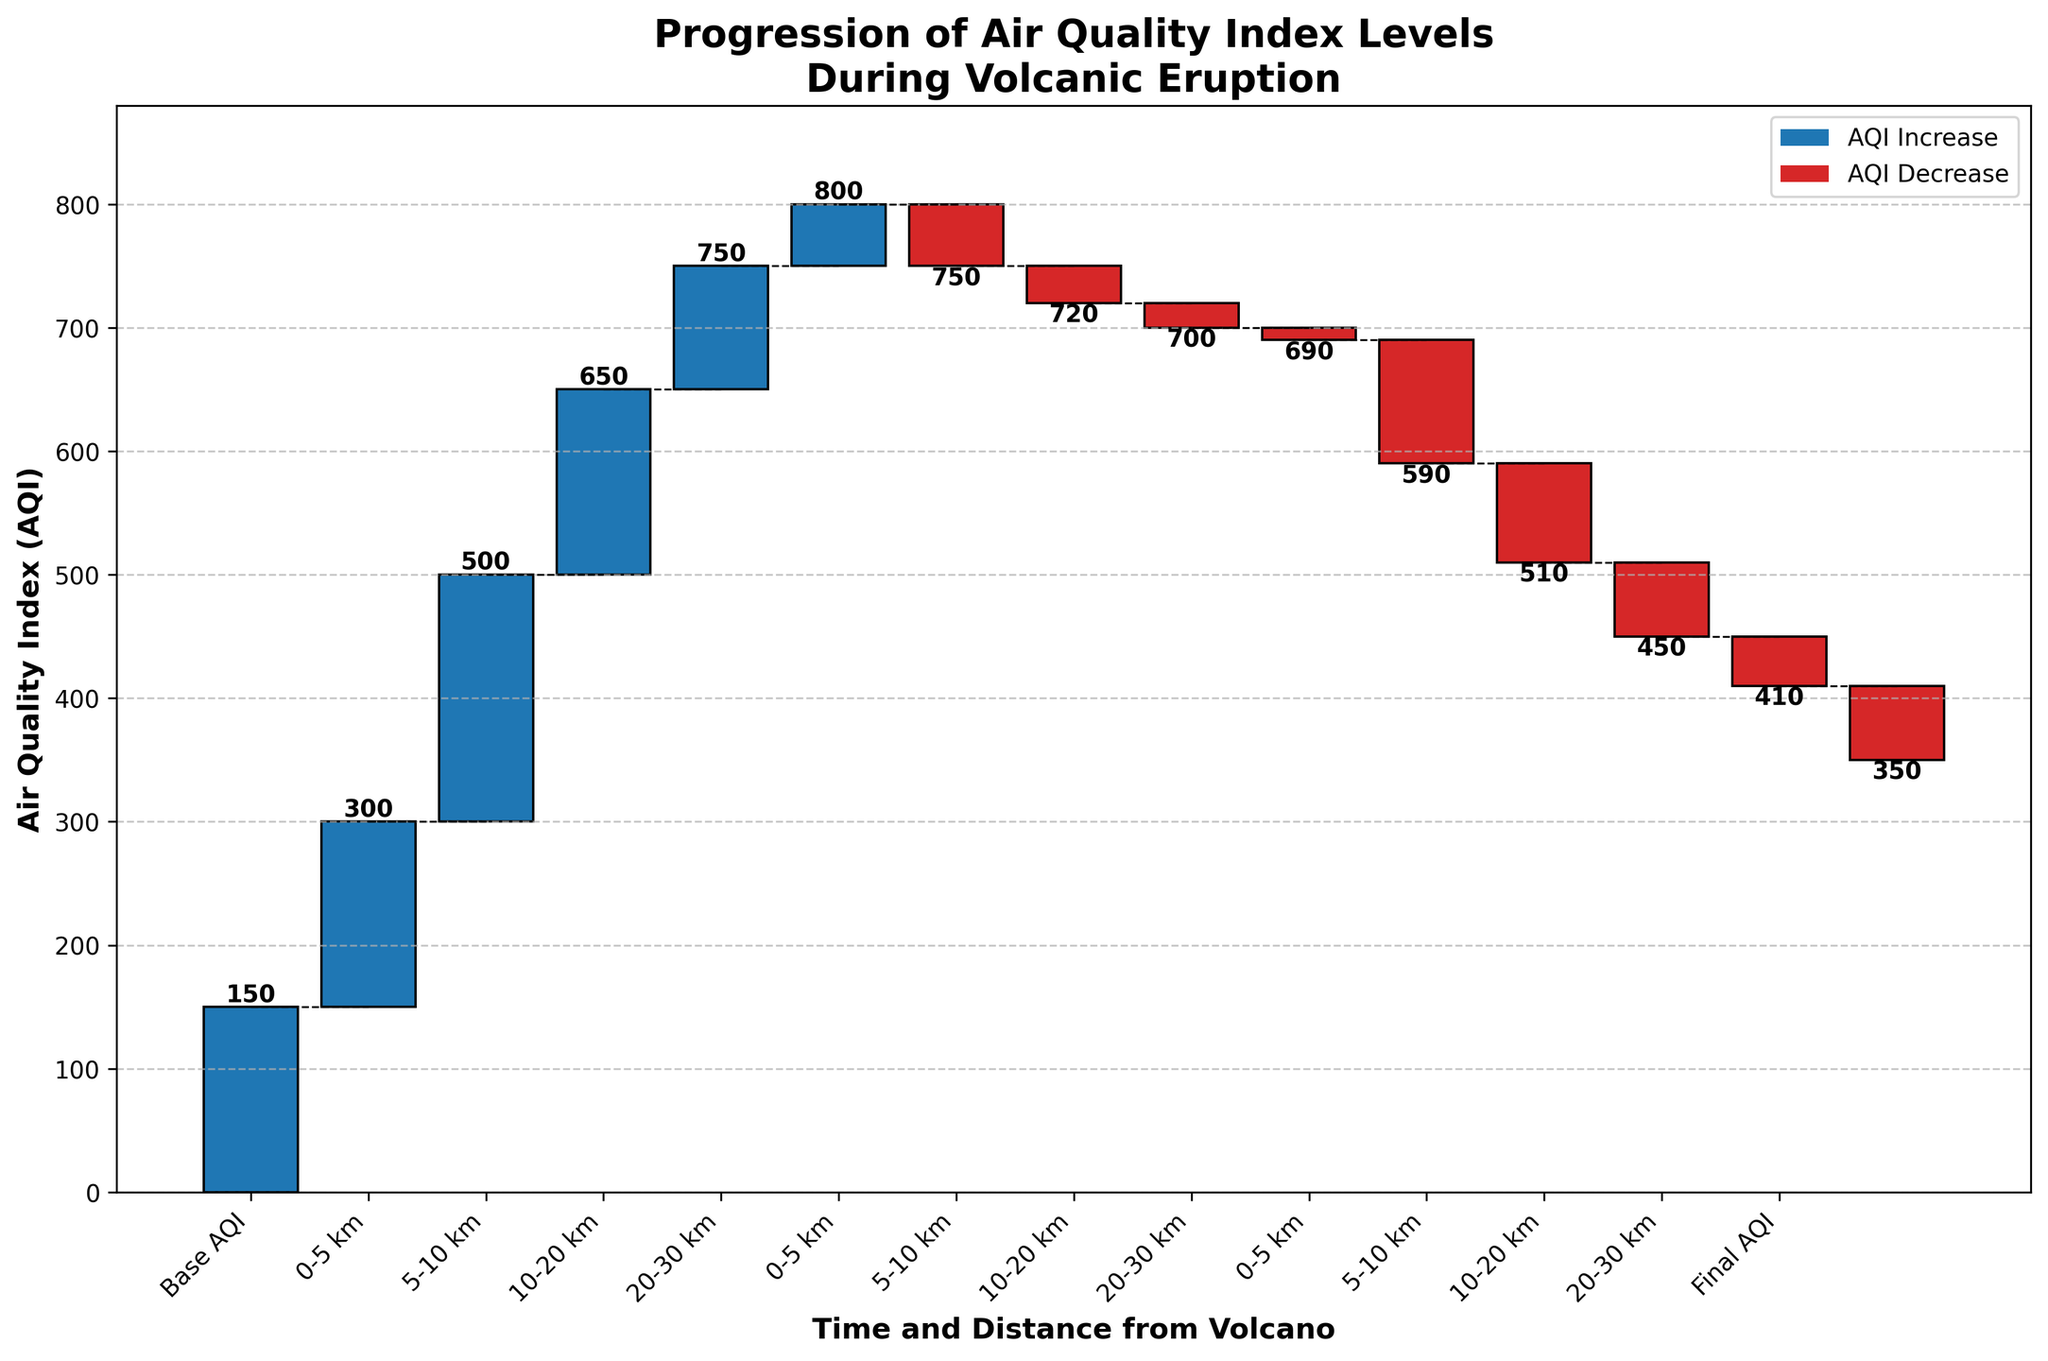what's the title of the chart? The title of the chart is displayed at the top and reads 'Progression of Air Quality Index Levels During Volcanic Eruption'.
Answer: Progression of Air Quality Index Levels During Volcanic Eruption How many intervals are depicted in the waterfall chart? The chart shows intervals from 'Base AQI' to 'Final AQI', covering multiple time and distance segments including 4 area segments at 6 hours, 4 segments at 12 hours, and 4 segments at 24 hours.
Answer: 12 What is the initial AQI value depicted on the chart? The initial AQI value is shown at the position of 'Base AQI' at the 0 mark on the horizontal axis.
Answer: 150 At which distance-time interval did the AQI see the highest increase? The intervals are marked on the horizontal axis, and the value with the highest increase is indicated with the tallest bar. The '0-5 km, 6 hours' interval has the largest increase with an AQI change of +200.
Answer: 0-5 km, 6 hours What is the final AQI value at the end of the 48 hours period? The final value is shown at the 'Final AQI' position on the x-axis, which after summing up all the changes, results in a cumulative AQI value.
Answer: 350 How much did the AQI change in the 5-10 km area over 24 hours? For 5-10 km, the AQI changes are provided for multiple intervals: +150 at 6 hours, -30 at 12 hours, and -80 at 24 hours. The net change is calculated by summing these values: +150 - 30 - 80 = +40.
Answer: +40 Compare the AQI change in the 0-5 km area between the 12-hour and 24-hour intervals. Which one had a greater decrease? The AQI changes in the 0-5 km area are -50 at 12 hours and -100 at 24 hours. The 24-hour interval had a greater decrease.
Answer: 24 hours Which distance-time interval experienced the least AQI change? By observing the heights of the bars, '20-30 km, 12 hours' sees the smallest change with an AQI shift of -10.
Answer: 20-30 km, 12 hours What is the total AQI increase after 6 hours for the entire region? To find this, add the AQI increases for all listed distances at the 6-hour mark: 200 (0-5 km) + 150 (5-10 km) + 100 (10-20 km) + 50 (20-30 km) = 500.
Answer: 500 